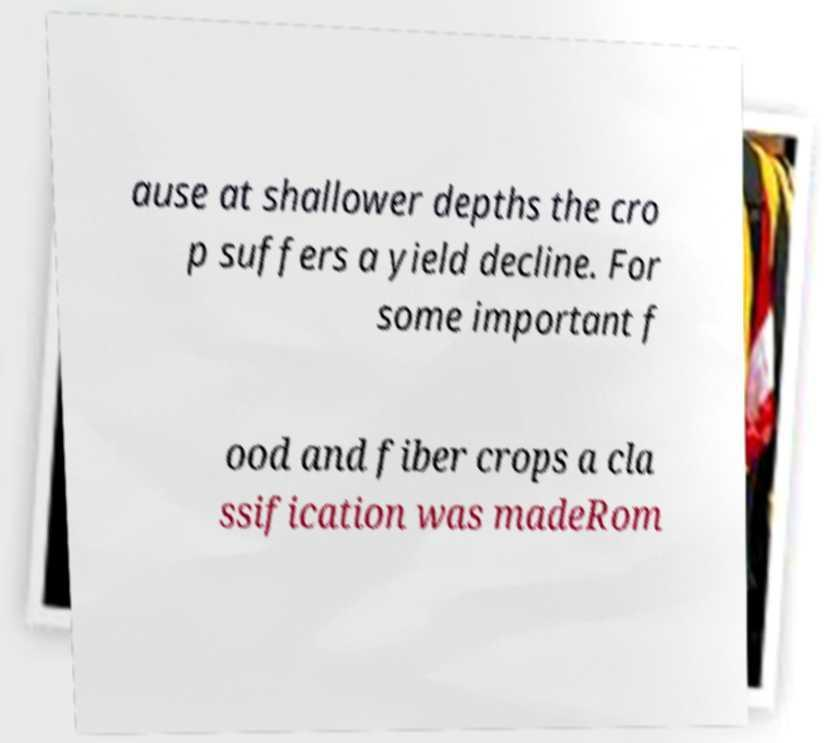Can you read and provide the text displayed in the image?This photo seems to have some interesting text. Can you extract and type it out for me? ause at shallower depths the cro p suffers a yield decline. For some important f ood and fiber crops a cla ssification was madeRom 